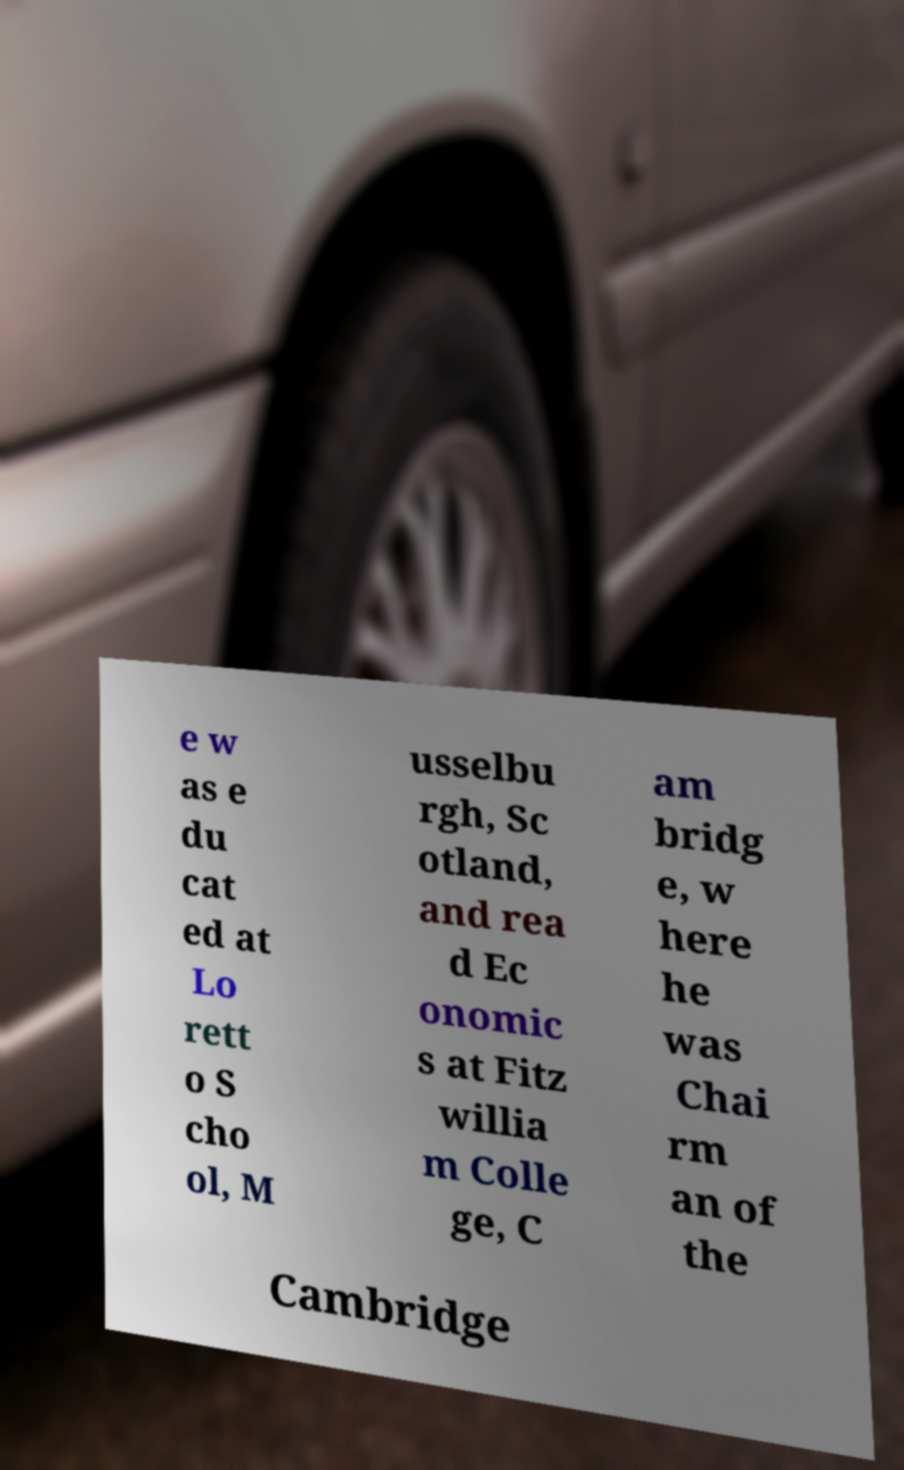For documentation purposes, I need the text within this image transcribed. Could you provide that? e w as e du cat ed at Lo rett o S cho ol, M usselbu rgh, Sc otland, and rea d Ec onomic s at Fitz willia m Colle ge, C am bridg e, w here he was Chai rm an of the Cambridge 